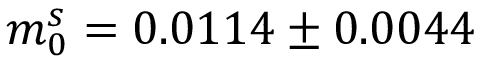<formula> <loc_0><loc_0><loc_500><loc_500>m _ { 0 } ^ { s } = 0 . 0 1 1 4 \pm 0 . 0 0 4 4</formula> 